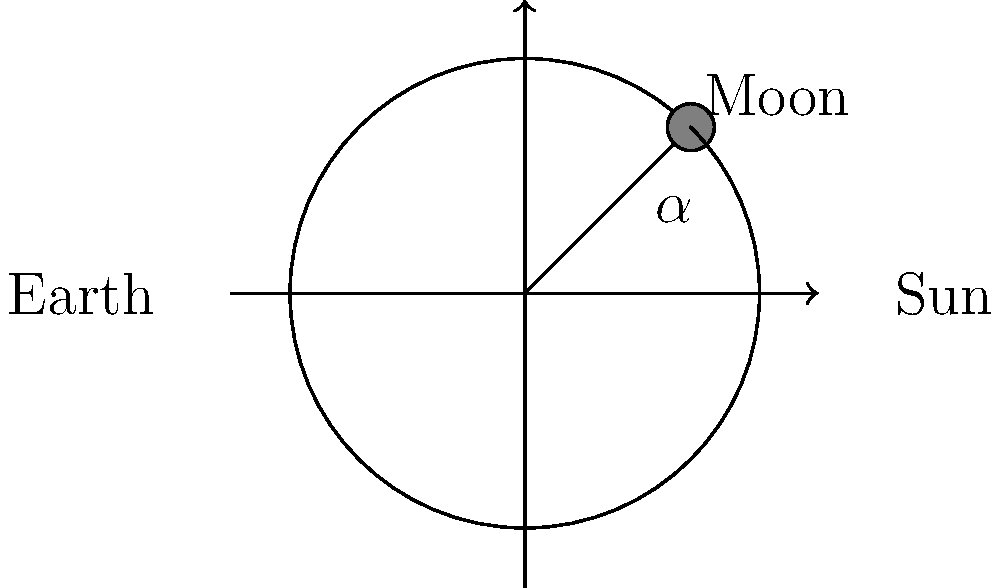Comrade, in our pursuit of scientific understanding for the betterment of our great nation, consider the diagram showing the Earth, Sun, and Moon. If the angle $\alpha$ between the Earth-Sun line and the Earth-Moon line is 45°, what percentage of the Moon's illuminated surface is visible from Earth? Let's approach this step-by-step, comrade:

1) The Moon's phases are determined by the relative positions of the Sun, Earth, and Moon.

2) The angle $\alpha$ represents the angular separation between the Sun and Moon as seen from Earth.

3) When $\alpha = 0°$, we have a New Moon (0% visible).
   When $\alpha = 90°$, we have a First Quarter Moon (50% visible).
   When $\alpha = 180°$, we have a Full Moon (100% visible).

4) The visible portion of the Moon increases linearly with $\alpha$ from 0° to 180°.

5) We can set up a proportion:
   $$\frac{\text{Visible portion}}{100\%} = \frac{\alpha}{180°}$$

6) Substituting $\alpha = 45°$:
   $$\frac{\text{Visible portion}}{100\%} = \frac{45°}{180°} = \frac{1}{4}$$

7) Solving for the visible portion:
   $$\text{Visible portion} = 100\% \cdot \frac{1}{4} = 25\%$$

Thus, when $\alpha = 45°$, 25% of the Moon's illuminated surface is visible from Earth.
Answer: 25% 